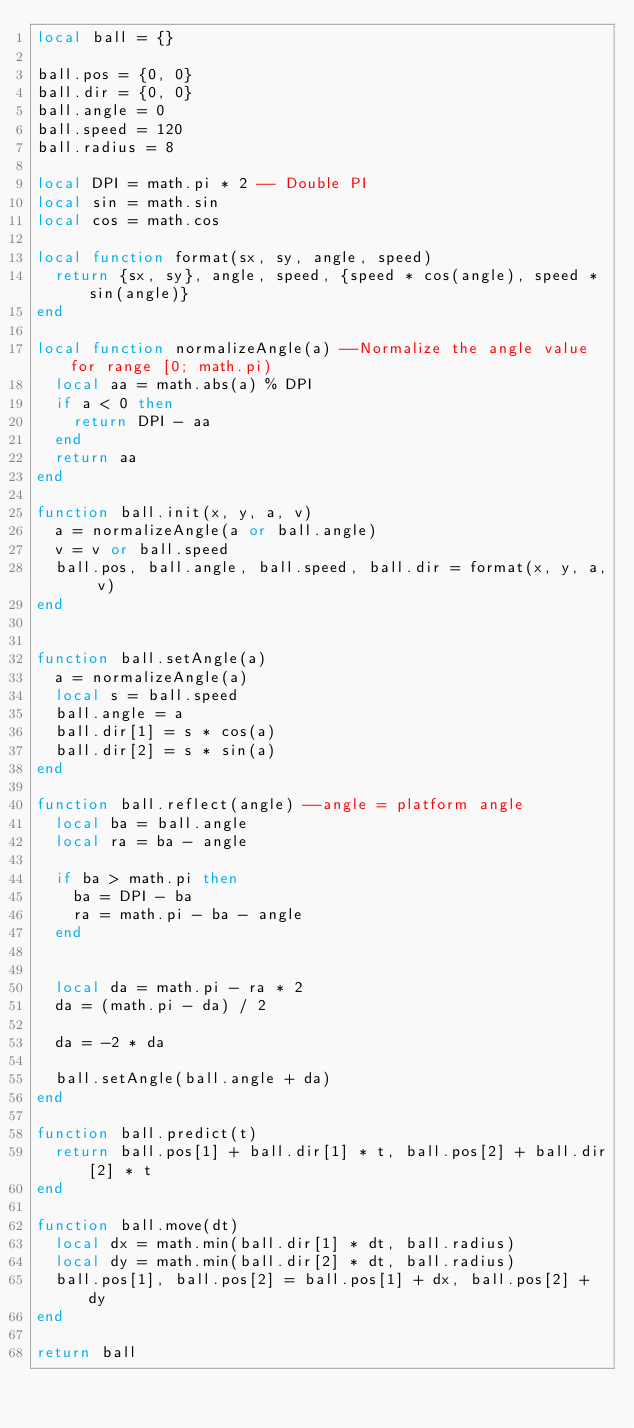<code> <loc_0><loc_0><loc_500><loc_500><_Lua_>local ball = {}

ball.pos = {0, 0}
ball.dir = {0, 0}
ball.angle = 0
ball.speed = 120
ball.radius = 8

local DPI = math.pi * 2 -- Double PI
local sin = math.sin
local cos = math.cos

local function format(sx, sy, angle, speed)
  return {sx, sy}, angle, speed, {speed * cos(angle), speed * sin(angle)}
end

local function normalizeAngle(a) --Normalize the angle value for range [0; math.pi)
  local aa = math.abs(a) % DPI
  if a < 0 then
    return DPI - aa
  end
  return aa
end

function ball.init(x, y, a, v)
  a = normalizeAngle(a or ball.angle)
  v = v or ball.speed
  ball.pos, ball.angle, ball.speed, ball.dir = format(x, y, a, v)
end


function ball.setAngle(a)
  a = normalizeAngle(a)
  local s = ball.speed
  ball.angle = a
  ball.dir[1] = s * cos(a)
  ball.dir[2] = s * sin(a)
end

function ball.reflect(angle) --angle = platform angle
  local ba = ball.angle
  local ra = ba - angle
  
  if ba > math.pi then
    ba = DPI - ba
    ra = math.pi - ba - angle
  end
  
  
  local da = math.pi - ra * 2
  da = (math.pi - da) / 2
  
  da = -2 * da
  
  ball.setAngle(ball.angle + da)
end

function ball.predict(t)
  return ball.pos[1] + ball.dir[1] * t, ball.pos[2] + ball.dir[2] * t
end

function ball.move(dt)
  local dx = math.min(ball.dir[1] * dt, ball.radius)
  local dy = math.min(ball.dir[2] * dt, ball.radius)
  ball.pos[1], ball.pos[2] = ball.pos[1] + dx, ball.pos[2] + dy
end

return ball</code> 